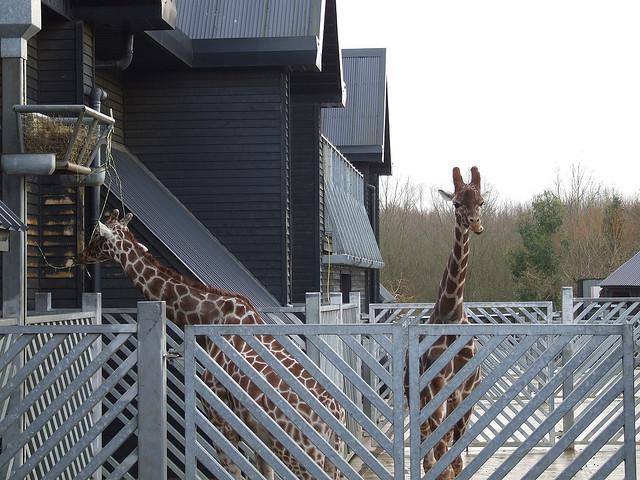How many giraffes can you see?
Give a very brief answer. 2. 